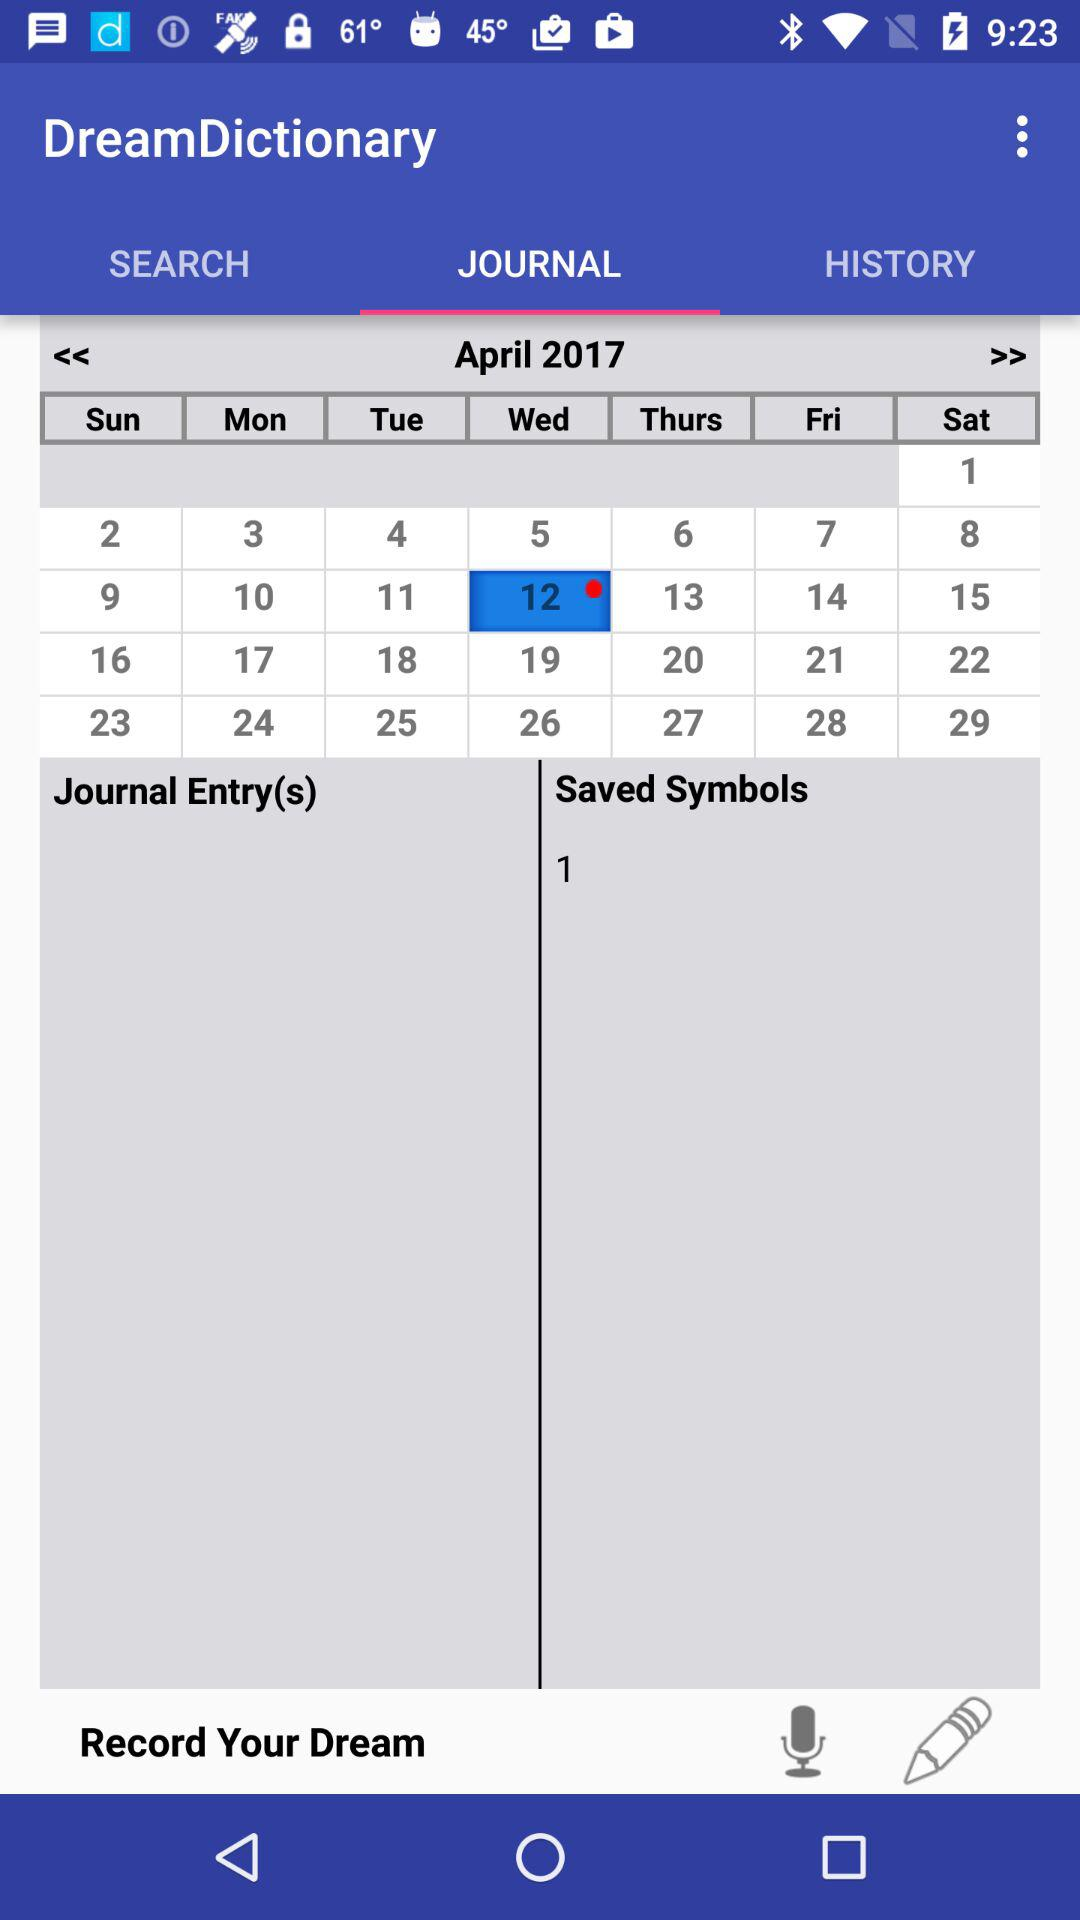Which tab is selected? The selected tab is "JOURNAL". 